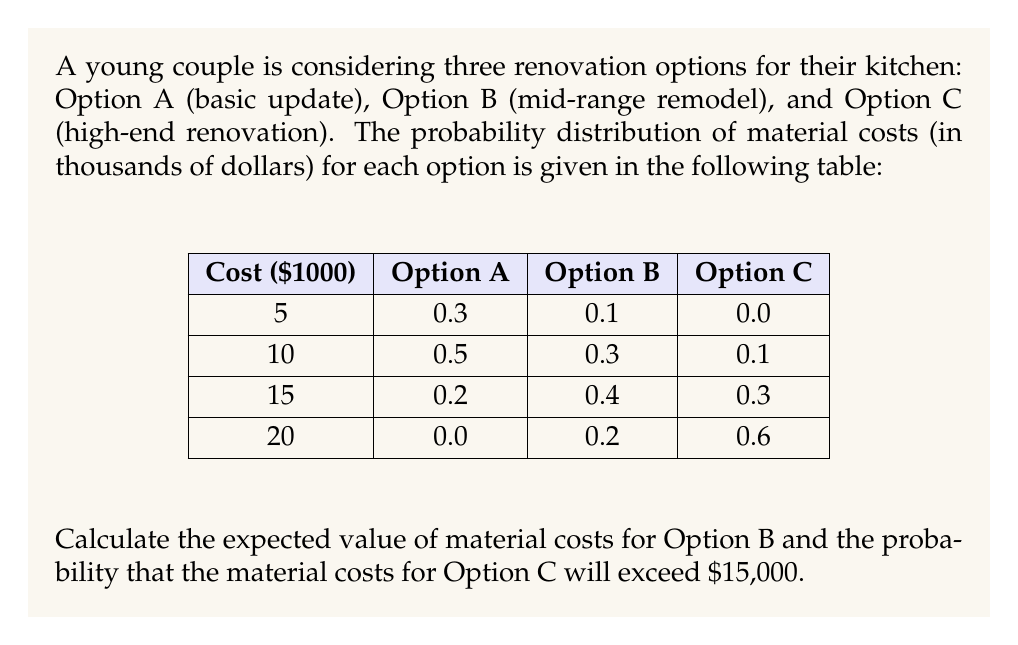Give your solution to this math problem. To solve this problem, we need to follow these steps:

1. Calculate the expected value of material costs for Option B:
   The expected value is calculated by multiplying each possible outcome by its probability and summing the results.

   $E(X) = \sum_{i=1}^{n} x_i \cdot p(x_i)$

   For Option B:
   $E(X_B) = 5 \cdot 0.1 + 10 \cdot 0.3 + 15 \cdot 0.4 + 20 \cdot 0.2$
   $E(X_B) = 0.5 + 3 + 6 + 4 = 13.5$

   The expected value of material costs for Option B is $13,500.

2. Calculate the probability that material costs for Option C will exceed $15,000:
   This probability is the sum of probabilities for all outcomes greater than $15,000.

   $P(X_C > 15) = P(X_C = 20)$
   $P(X_C > 15) = 0.6$

   The probability that material costs for Option C will exceed $15,000 is 0.6 or 60%.
Answer: Expected value for Option B: $13,500; Probability of Option C exceeding $15,000: 0.6 